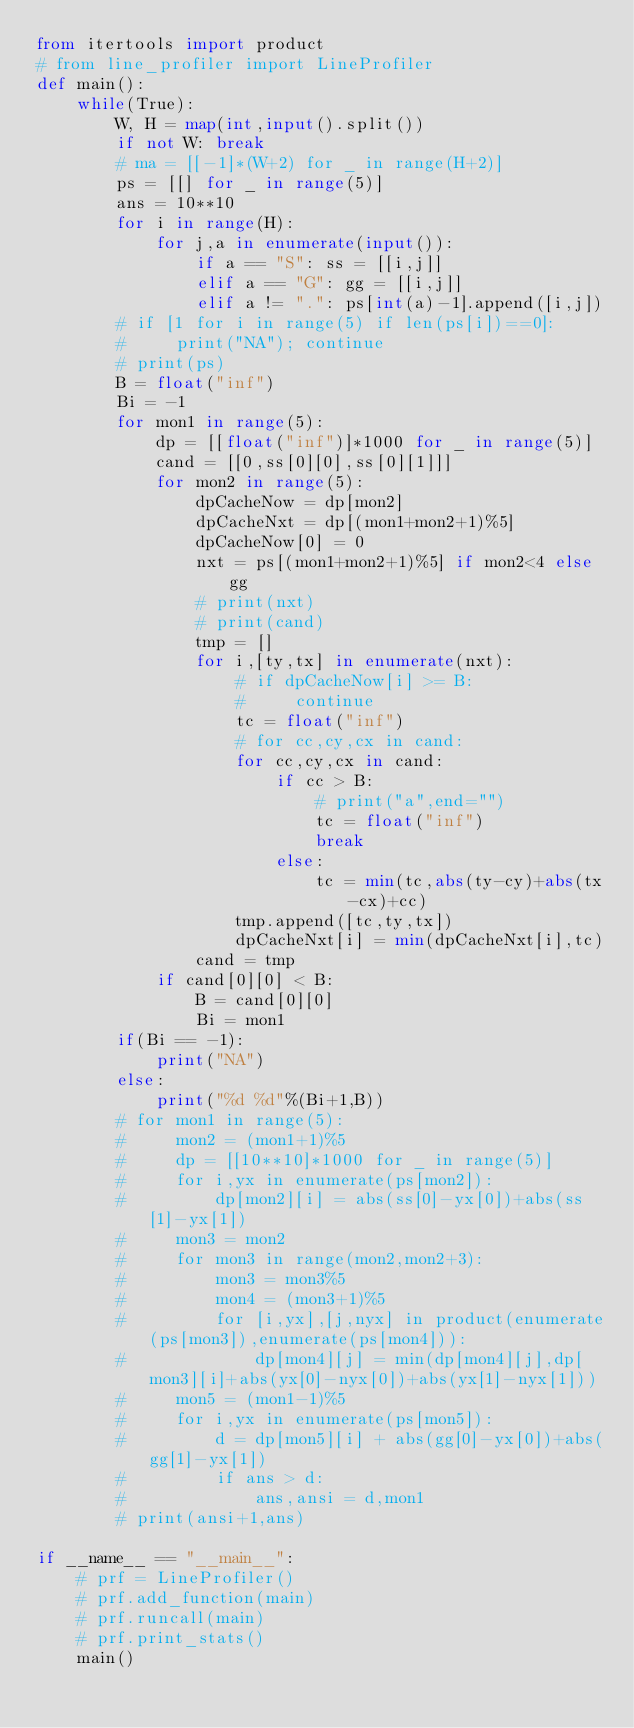<code> <loc_0><loc_0><loc_500><loc_500><_Python_>from itertools import product
# from line_profiler import LineProfiler
def main():
    while(True):
        W, H = map(int,input().split())
        if not W: break
        # ma = [[-1]*(W+2) for _ in range(H+2)]
        ps = [[] for _ in range(5)]
        ans = 10**10
        for i in range(H):
            for j,a in enumerate(input()):
                if a == "S": ss = [[i,j]]
                elif a == "G": gg = [[i,j]]
                elif a != ".": ps[int(a)-1].append([i,j])
        # if [1 for i in range(5) if len(ps[i])==0]:
        #     print("NA"); continue
        # print(ps)
        B = float("inf")
        Bi = -1
        for mon1 in range(5):
            dp = [[float("inf")]*1000 for _ in range(5)]
            cand = [[0,ss[0][0],ss[0][1]]]
            for mon2 in range(5):
                dpCacheNow = dp[mon2]
                dpCacheNxt = dp[(mon1+mon2+1)%5]
                dpCacheNow[0] = 0
                nxt = ps[(mon1+mon2+1)%5] if mon2<4 else gg
                # print(nxt)
                # print(cand)
                tmp = []
                for i,[ty,tx] in enumerate(nxt):
                    # if dpCacheNow[i] >= B:
                    #     continue
                    tc = float("inf")
                    # for cc,cy,cx in cand:
                    for cc,cy,cx in cand:
                        if cc > B:
                            # print("a",end="")
                            tc = float("inf")
                            break
                        else:
                            tc = min(tc,abs(ty-cy)+abs(tx-cx)+cc)
                    tmp.append([tc,ty,tx])
                    dpCacheNxt[i] = min(dpCacheNxt[i],tc)
                cand = tmp
            if cand[0][0] < B:
                B = cand[0][0]
                Bi = mon1
        if(Bi == -1):
            print("NA")
        else:
            print("%d %d"%(Bi+1,B))
        # for mon1 in range(5):
        #     mon2 = (mon1+1)%5
        #     dp = [[10**10]*1000 for _ in range(5)]
        #     for i,yx in enumerate(ps[mon2]):
        #         dp[mon2][i] = abs(ss[0]-yx[0])+abs(ss[1]-yx[1])
        #     mon3 = mon2
        #     for mon3 in range(mon2,mon2+3):
        #         mon3 = mon3%5
        #         mon4 = (mon3+1)%5
        #         for [i,yx],[j,nyx] in product(enumerate(ps[mon3]),enumerate(ps[mon4])):
        #             dp[mon4][j] = min(dp[mon4][j],dp[mon3][i]+abs(yx[0]-nyx[0])+abs(yx[1]-nyx[1]))
        #     mon5 = (mon1-1)%5
        #     for i,yx in enumerate(ps[mon5]):
        #         d = dp[mon5][i] + abs(gg[0]-yx[0])+abs(gg[1]-yx[1])
        #         if ans > d:
        #             ans,ansi = d,mon1
        # print(ansi+1,ans)

if __name__ == "__main__":
    # prf = LineProfiler()
    # prf.add_function(main)
    # prf.runcall(main)
    # prf.print_stats()
    main()
</code> 